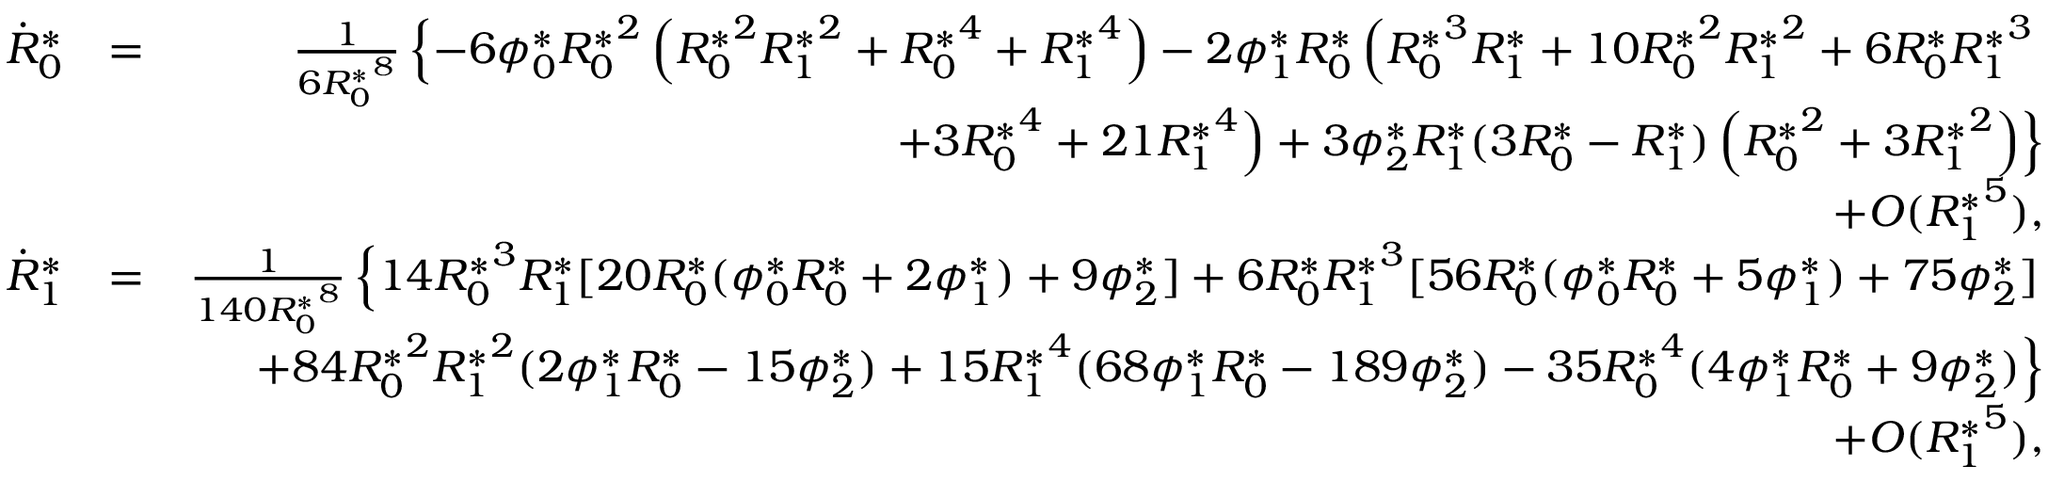Convert formula to latex. <formula><loc_0><loc_0><loc_500><loc_500>\begin{array} { r l r } { \dot { R } _ { 0 } ^ { * } } & { = } & { \frac { 1 } { 6 { R _ { 0 } ^ { * } } ^ { 8 } } \left \{ - 6 { \phi _ { 0 } ^ { * } } { R _ { 0 } ^ { * } } ^ { 2 } \left ( { R _ { 0 } ^ { * } } ^ { 2 } { R _ { 1 } ^ { * } } ^ { 2 } + { R _ { 0 } ^ { * } } ^ { 4 } + { R _ { 1 } ^ { * } } ^ { 4 } \right ) - 2 { \phi _ { 1 } ^ { * } } { R _ { 0 } ^ { * } } \left ( { R _ { 0 } ^ { * } } ^ { 3 } { R _ { 1 } ^ { * } } + 1 0 { R _ { 0 } ^ { * } } ^ { 2 } { R _ { 1 } ^ { * } } ^ { 2 } + 6 { R _ { 0 } ^ { * } } { R _ { 1 } ^ { * } } ^ { 3 } } \\ & { + 3 { R _ { 0 } ^ { * } } ^ { 4 } + 2 1 { R _ { 1 } ^ { * } } ^ { 4 } \right ) + 3 { \phi _ { 2 } ^ { * } } { R _ { 1 } ^ { * } } ( 3 { R _ { 0 } ^ { * } } - { R _ { 1 } ^ { * } } ) \left ( { R _ { 0 } ^ { * } } ^ { 2 } + 3 { R _ { 1 } ^ { * } } ^ { 2 } \right ) \right \} } \\ & { + O ( { R _ { 1 } ^ { * } } ^ { 5 } ) , } \\ { \dot { R } _ { 1 } ^ { * } } & { = } & { \frac { 1 } { 1 4 0 { R _ { 0 } ^ { * } } ^ { 8 } } \left \{ 1 4 { R _ { 0 } ^ { * } } ^ { 3 } { R _ { 1 } ^ { * } } [ 2 0 { R _ { 0 } ^ { * } } ( { \phi _ { 0 } ^ { * } } { R _ { 0 } ^ { * } } + 2 { \phi _ { 1 } ^ { * } } ) + 9 { \phi _ { 2 } ^ { * } } ] + 6 { R _ { 0 } ^ { * } } { R _ { 1 } ^ { * } } ^ { 3 } [ 5 6 { R _ { 0 } ^ { * } } ( { \phi _ { 0 } ^ { * } } { R _ { 0 } ^ { * } } + 5 { \phi _ { 1 } ^ { * } } ) + 7 5 { \phi _ { 2 } ^ { * } } ] } \\ & { + 8 4 { R _ { 0 } ^ { * } } ^ { 2 } { R _ { 1 } ^ { * } } ^ { 2 } ( 2 { \phi _ { 1 } ^ { * } } { R _ { 0 } ^ { * } } - 1 5 { \phi _ { 2 } ^ { * } } ) + 1 5 { R _ { 1 } ^ { * } } ^ { 4 } ( 6 8 { \phi _ { 1 } ^ { * } } { R _ { 0 } ^ { * } } - 1 8 9 { \phi _ { 2 } ^ { * } } ) - 3 5 { R _ { 0 } ^ { * } } ^ { 4 } ( 4 { \phi _ { 1 } ^ { * } } { R _ { 0 } ^ { * } } + 9 { \phi _ { 2 } ^ { * } } ) \right \} } \\ & { + O ( { R _ { 1 } ^ { * } } ^ { 5 } ) , } \end{array}</formula> 